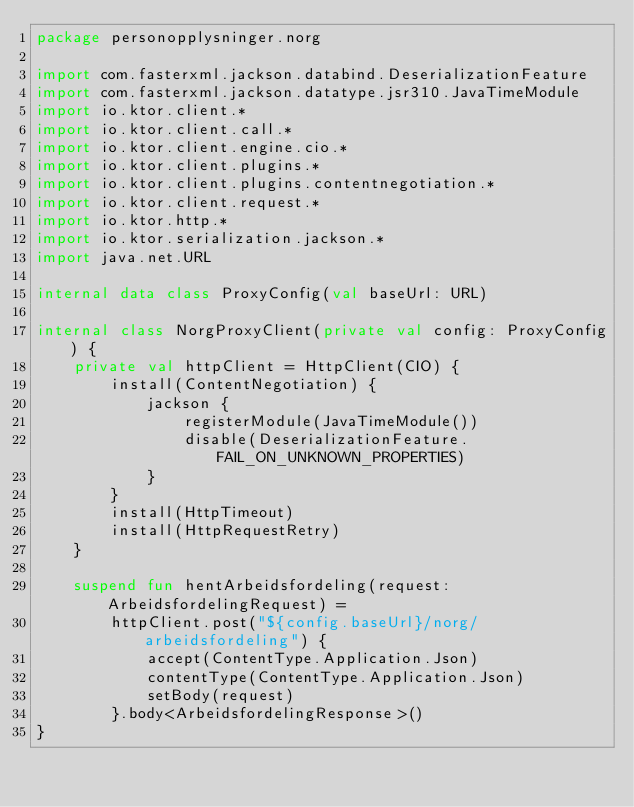Convert code to text. <code><loc_0><loc_0><loc_500><loc_500><_Kotlin_>package personopplysninger.norg

import com.fasterxml.jackson.databind.DeserializationFeature
import com.fasterxml.jackson.datatype.jsr310.JavaTimeModule
import io.ktor.client.*
import io.ktor.client.call.*
import io.ktor.client.engine.cio.*
import io.ktor.client.plugins.*
import io.ktor.client.plugins.contentnegotiation.*
import io.ktor.client.request.*
import io.ktor.http.*
import io.ktor.serialization.jackson.*
import java.net.URL

internal data class ProxyConfig(val baseUrl: URL)

internal class NorgProxyClient(private val config: ProxyConfig) {
    private val httpClient = HttpClient(CIO) {
        install(ContentNegotiation) {
            jackson {
                registerModule(JavaTimeModule())
                disable(DeserializationFeature.FAIL_ON_UNKNOWN_PROPERTIES)
            }
        }
        install(HttpTimeout)
        install(HttpRequestRetry)
    }

    suspend fun hentArbeidsfordeling(request: ArbeidsfordelingRequest) =
        httpClient.post("${config.baseUrl}/norg/arbeidsfordeling") {
            accept(ContentType.Application.Json)
            contentType(ContentType.Application.Json)
            setBody(request)
        }.body<ArbeidsfordelingResponse>()
}
</code> 